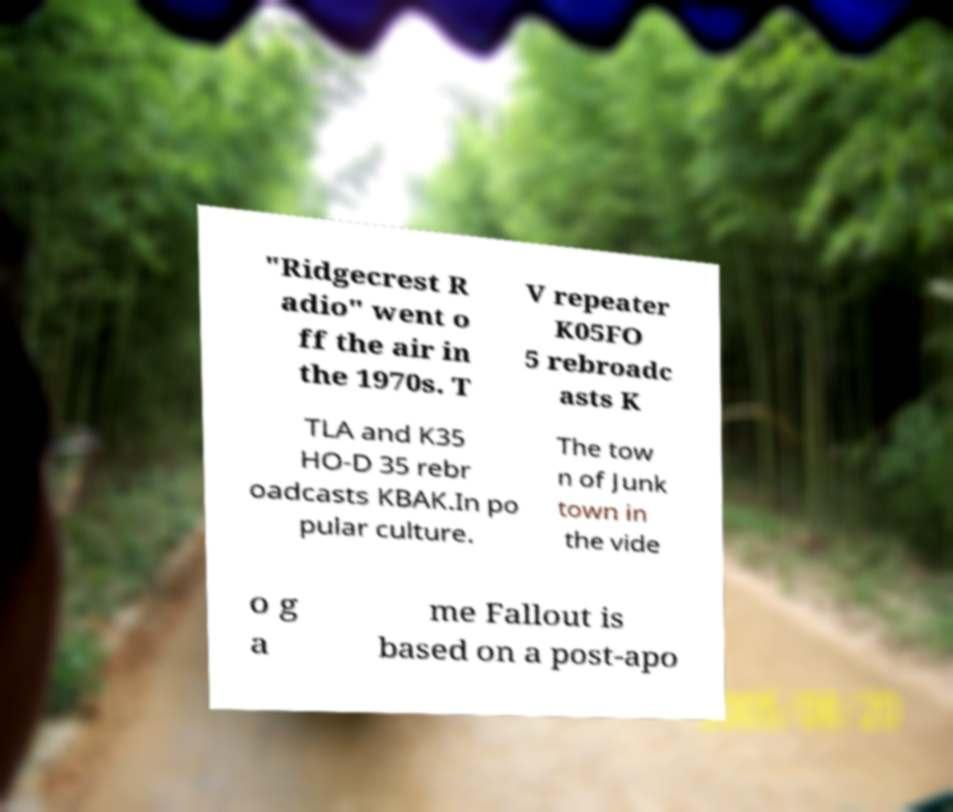Could you extract and type out the text from this image? "Ridgecrest R adio" went o ff the air in the 1970s. T V repeater K05FO 5 rebroadc asts K TLA and K35 HO-D 35 rebr oadcasts KBAK.In po pular culture. The tow n of Junk town in the vide o g a me Fallout is based on a post-apo 